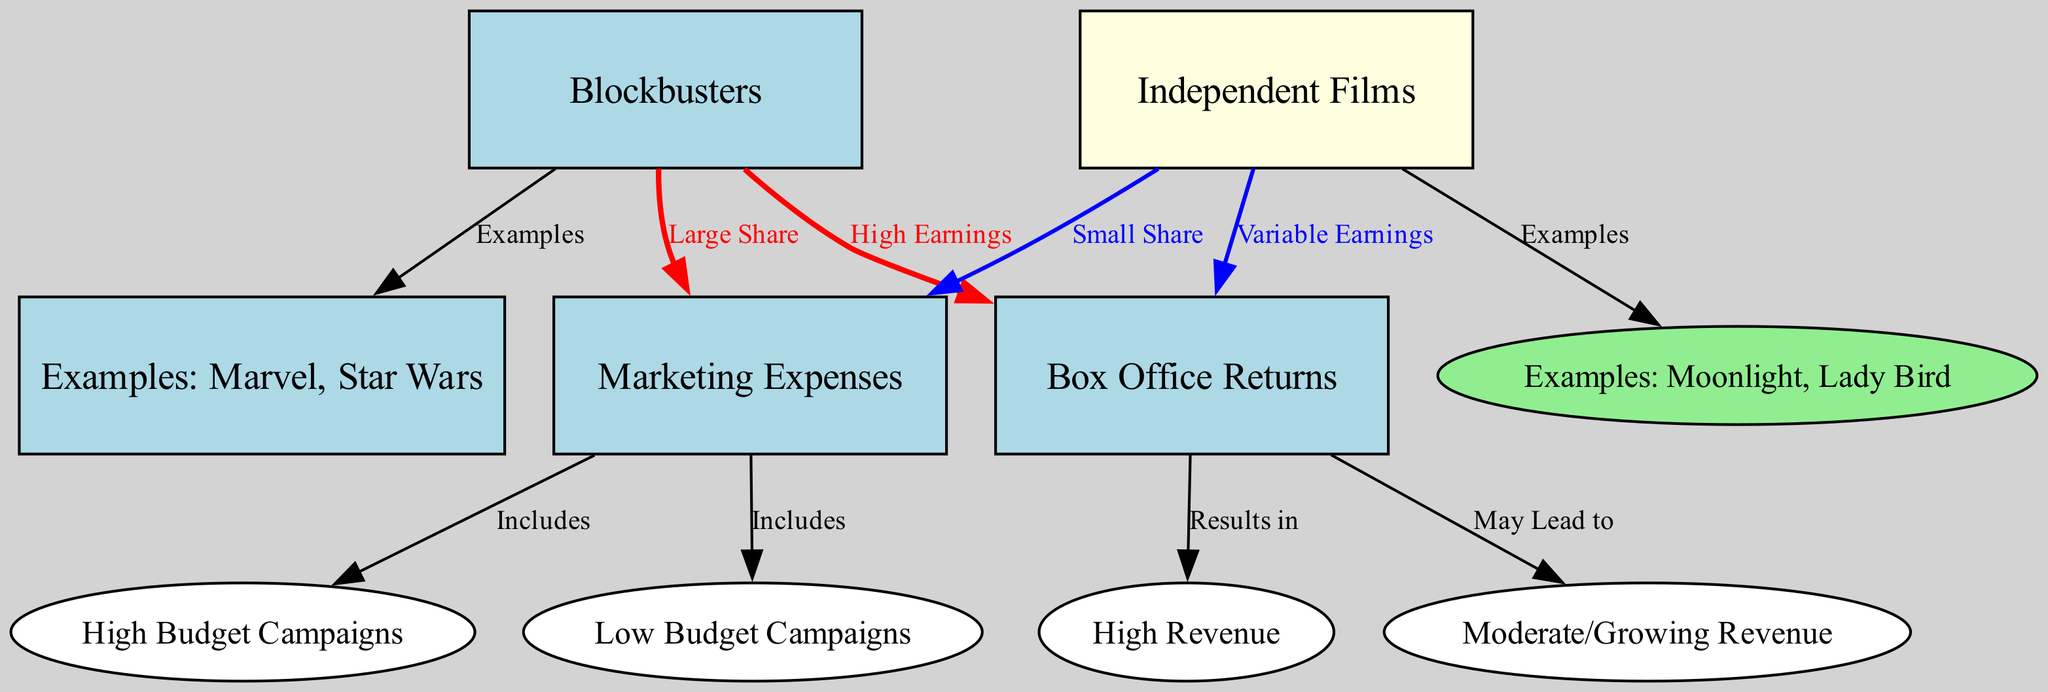What types of films have large marketing expenses? The diagram indicates that blockbusters have "Large Share" of marketing expenses. Connect the node for blockbusters with the edge label "Large Share" leading to marketing expenses.
Answer: Blockbusters What are examples of blockbusters according to the diagram? The node connected to blockbusters with the label "Examples" lists "Marvel, Star Wars." Tracing this edge reveals the examples provided in the diagram.
Answer: Marvel, Star Wars Which type of films have variable box office returns? The edge from independent films to box office returns is labeled "May Lead to," indicating that independent films may not have consistent earnings, therefore they are variable.
Answer: Independent films How do marketing expenses differ between blockbusters and independent films? The diagram shows that marketing expenses for blockbusters involve "High Budget Campaigns" while independent films involve "Low Budget Campaigns." This establishes the contrast in their marketing approaches.
Answer: High Budget Campaigns vs. Low Budget Campaigns What is the relationship between box office returns and blockbuster earnings? The edge labeled "Results in" connects box office returns to "High Revenue" specifically for blockbusters, demonstrating the outcome of their higher marketing efforts resulting in higher returns.
Answer: High Revenue How many nodes represent film types in this diagram? The diagram features two distinct types of films: blockbusters and independent films. By counting the nodes identified as film types, we find there are only two.
Answer: Two What is the typical outcome of marketing expenses for independent films? The marketing expenses for independent films are described with the edge label as "Includes" leading to "Low Budget Campaigns," leading to an understanding that the marketing outcomes may lead to moderate revenues but are not as high as blockbusters.
Answer: Moderate/Growing Revenue What is indicated by the edge labeled "Small Share"? This edge, which connects independent films to marketing expenses, indicates that independent films account for a smaller portion of total marketing expenses compared to blockbusters, highlighting the relative scale of their campaigns.
Answer: Small Share What can we conclude about the overall revenue potential of blockbusters? The connection from box office returns to the blockbusters node, along with the label "High Earnings," indicates that they have a solid potential for generating substantial revenue compared to independent films.
Answer: High Earnings 